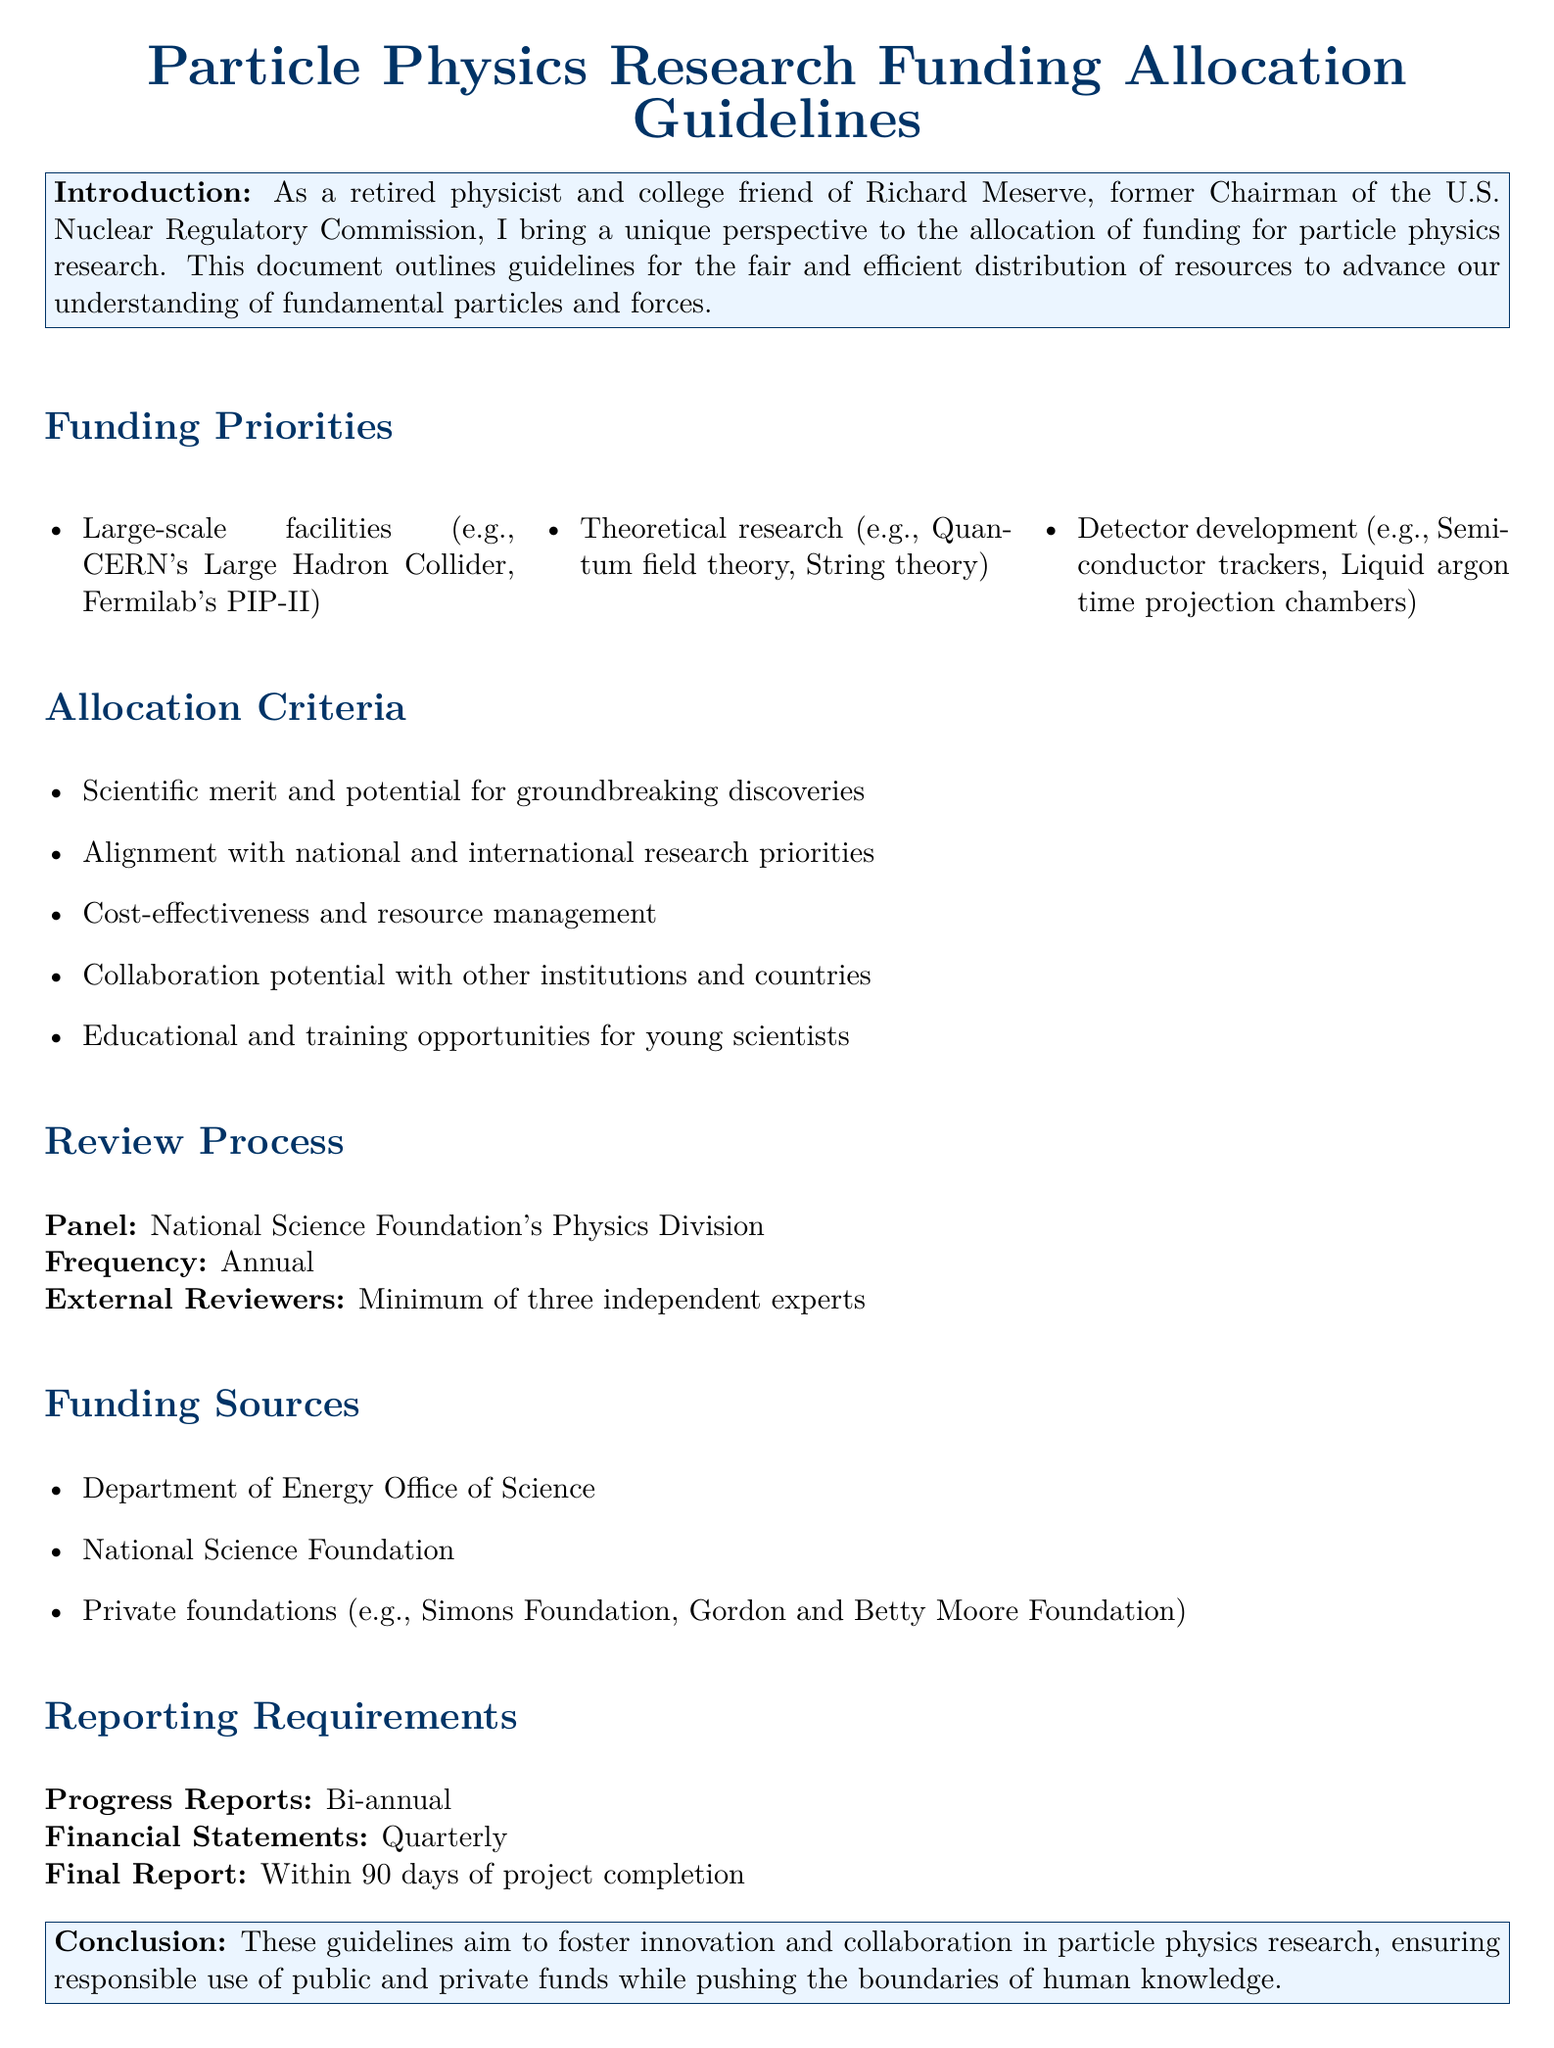What are the funding priorities for particle physics research? The funding priorities include large-scale facilities, theoretical research, and detector development.
Answer: Large-scale facilities, theoretical research, detector development How frequently does the review process occur? The document states that the review process occurs annually.
Answer: Annual Who are the external reviewers in the review process? The document specifies that a minimum of three independent experts serve as external reviewers.
Answer: Minimum of three independent experts What is one criterion for funding allocation mentioned in the document? The document lists scientific merit and potential for groundbreaking discoveries as one of the criteria for funding allocation.
Answer: Scientific merit and potential for groundbreaking discoveries What is the deadline for the final report after project completion? The document indicates that the final report is required within 90 days of project completion.
Answer: Within 90 days Which organization is mentioned as a funding source? The document lists the Department of Energy Office of Science as one of the funding sources.
Answer: Department of Energy Office of Science What is the purpose of these guidelines? The guidelines aim to foster innovation and collaboration in particle physics research.
Answer: Foster innovation and collaboration What is the minimum number of external reviewers for the review process? According to the document, there should be a minimum of three external reviewers.
Answer: Minimum of three What do progress reports need to be submitted? The document states that progress reports need to be submitted bi-annually.
Answer: Bi-annual 